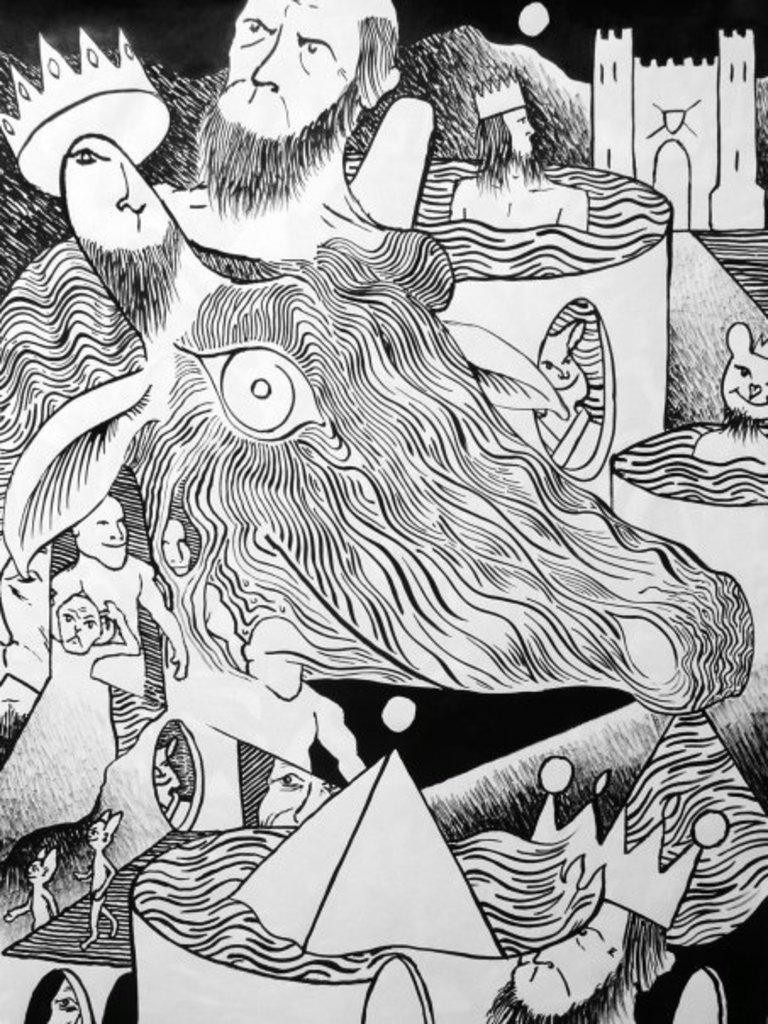How would you summarize this image in a sentence or two? In this image I can see a sketch and I can see color of this sketch is black and white. 